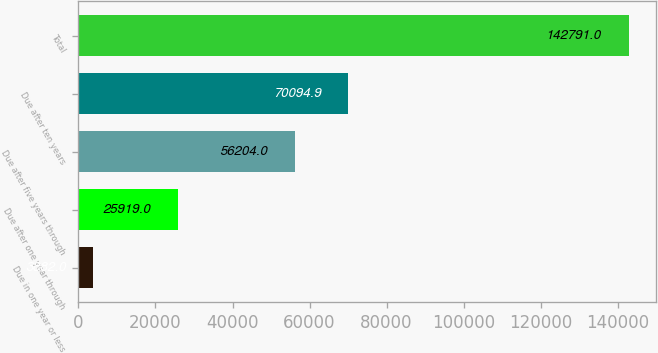Convert chart to OTSL. <chart><loc_0><loc_0><loc_500><loc_500><bar_chart><fcel>Due in one year or less<fcel>Due after one year through<fcel>Due after five years through<fcel>Due after ten years<fcel>Total<nl><fcel>3882<fcel>25919<fcel>56204<fcel>70094.9<fcel>142791<nl></chart> 